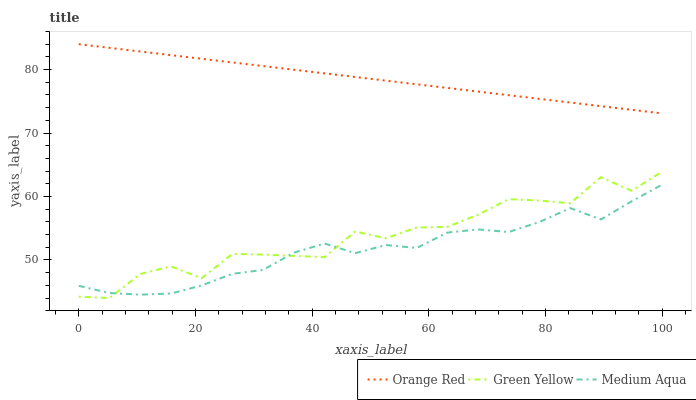Does Orange Red have the minimum area under the curve?
Answer yes or no. No. Does Medium Aqua have the maximum area under the curve?
Answer yes or no. No. Is Medium Aqua the smoothest?
Answer yes or no. No. Is Medium Aqua the roughest?
Answer yes or no. No. Does Medium Aqua have the lowest value?
Answer yes or no. No. Does Medium Aqua have the highest value?
Answer yes or no. No. Is Medium Aqua less than Orange Red?
Answer yes or no. Yes. Is Orange Red greater than Medium Aqua?
Answer yes or no. Yes. Does Medium Aqua intersect Orange Red?
Answer yes or no. No. 